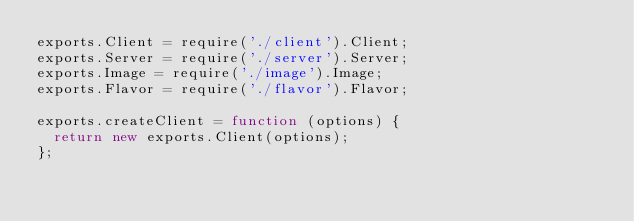<code> <loc_0><loc_0><loc_500><loc_500><_JavaScript_>exports.Client = require('./client').Client;
exports.Server = require('./server').Server;
exports.Image = require('./image').Image;
exports.Flavor = require('./flavor').Flavor;

exports.createClient = function (options) {
  return new exports.Client(options);
};
</code> 